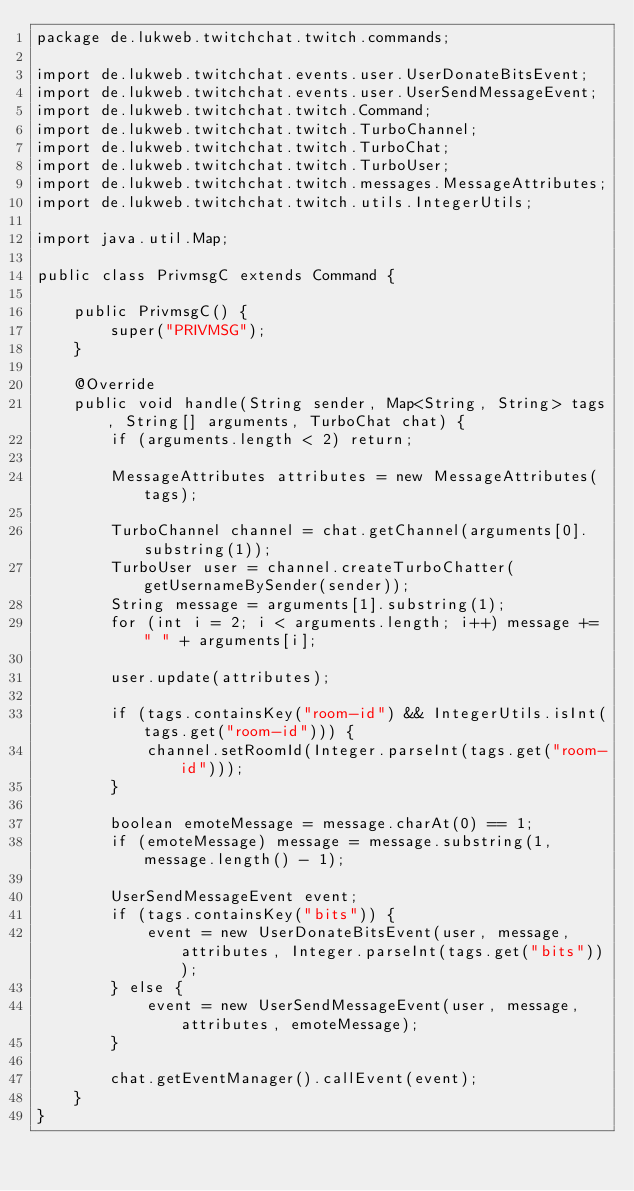Convert code to text. <code><loc_0><loc_0><loc_500><loc_500><_Java_>package de.lukweb.twitchchat.twitch.commands;

import de.lukweb.twitchchat.events.user.UserDonateBitsEvent;
import de.lukweb.twitchchat.events.user.UserSendMessageEvent;
import de.lukweb.twitchchat.twitch.Command;
import de.lukweb.twitchchat.twitch.TurboChannel;
import de.lukweb.twitchchat.twitch.TurboChat;
import de.lukweb.twitchchat.twitch.TurboUser;
import de.lukweb.twitchchat.twitch.messages.MessageAttributes;
import de.lukweb.twitchchat.twitch.utils.IntegerUtils;

import java.util.Map;

public class PrivmsgC extends Command {

    public PrivmsgC() {
        super("PRIVMSG");
    }

    @Override
    public void handle(String sender, Map<String, String> tags, String[] arguments, TurboChat chat) {
        if (arguments.length < 2) return;

        MessageAttributes attributes = new MessageAttributes(tags);

        TurboChannel channel = chat.getChannel(arguments[0].substring(1));
        TurboUser user = channel.createTurboChatter(getUsernameBySender(sender));
        String message = arguments[1].substring(1);
        for (int i = 2; i < arguments.length; i++) message += " " + arguments[i];

        user.update(attributes);

        if (tags.containsKey("room-id") && IntegerUtils.isInt(tags.get("room-id"))) {
            channel.setRoomId(Integer.parseInt(tags.get("room-id")));
        }

        boolean emoteMessage = message.charAt(0) == 1;
        if (emoteMessage) message = message.substring(1, message.length() - 1);

        UserSendMessageEvent event;
        if (tags.containsKey("bits")) {
            event = new UserDonateBitsEvent(user, message, attributes, Integer.parseInt(tags.get("bits")));
        } else {
            event = new UserSendMessageEvent(user, message, attributes, emoteMessage);
        }

        chat.getEventManager().callEvent(event);
    }
}
</code> 